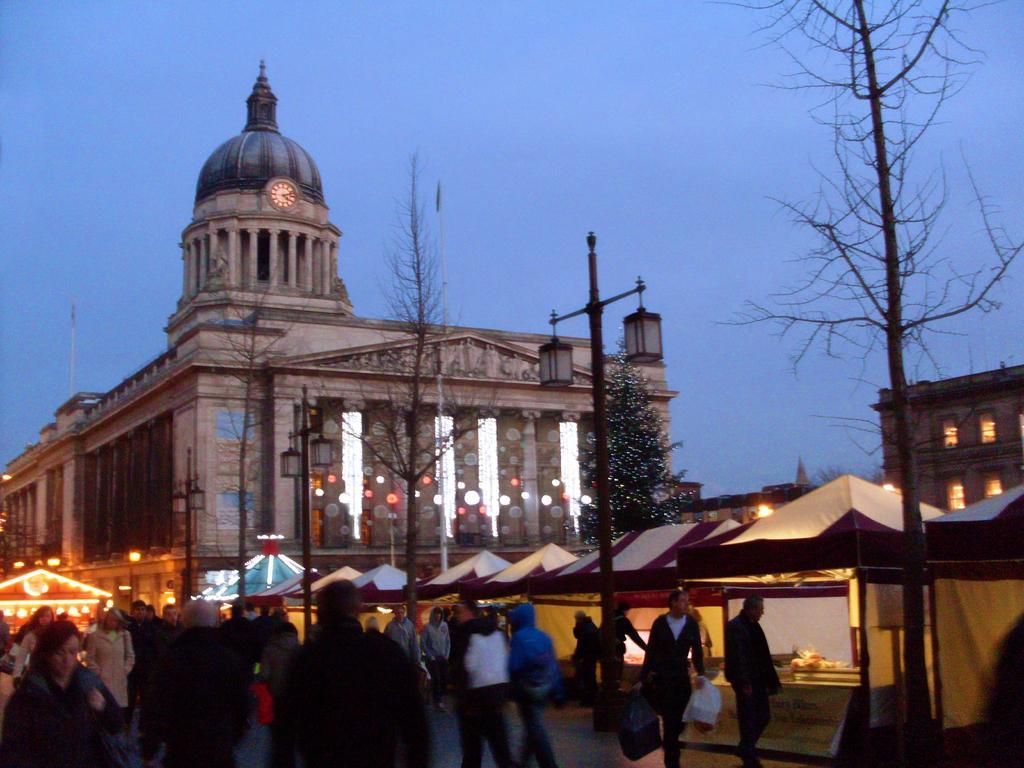Describe this image in one or two sentences. This picture is clicked outside the city. At the bottom of the picture, we see people walking on the road. Beside them, we see stalls and white tents. On the right side, we see a building and trees. We even see a light pole. In the background, we see a council house. At the top of the picture, we see the sky, which is blue in color. 